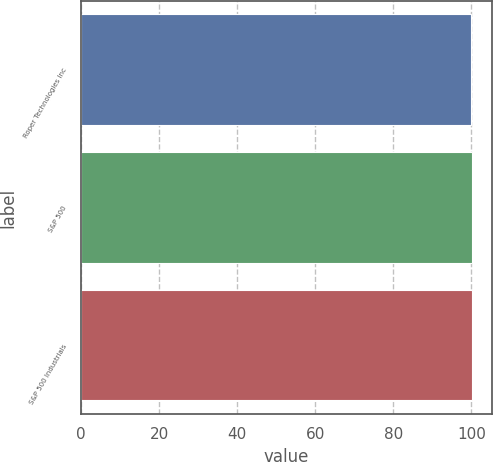<chart> <loc_0><loc_0><loc_500><loc_500><bar_chart><fcel>Roper Technologies Inc<fcel>S&P 500<fcel>S&P 500 Industrials<nl><fcel>100<fcel>100.1<fcel>100.2<nl></chart> 